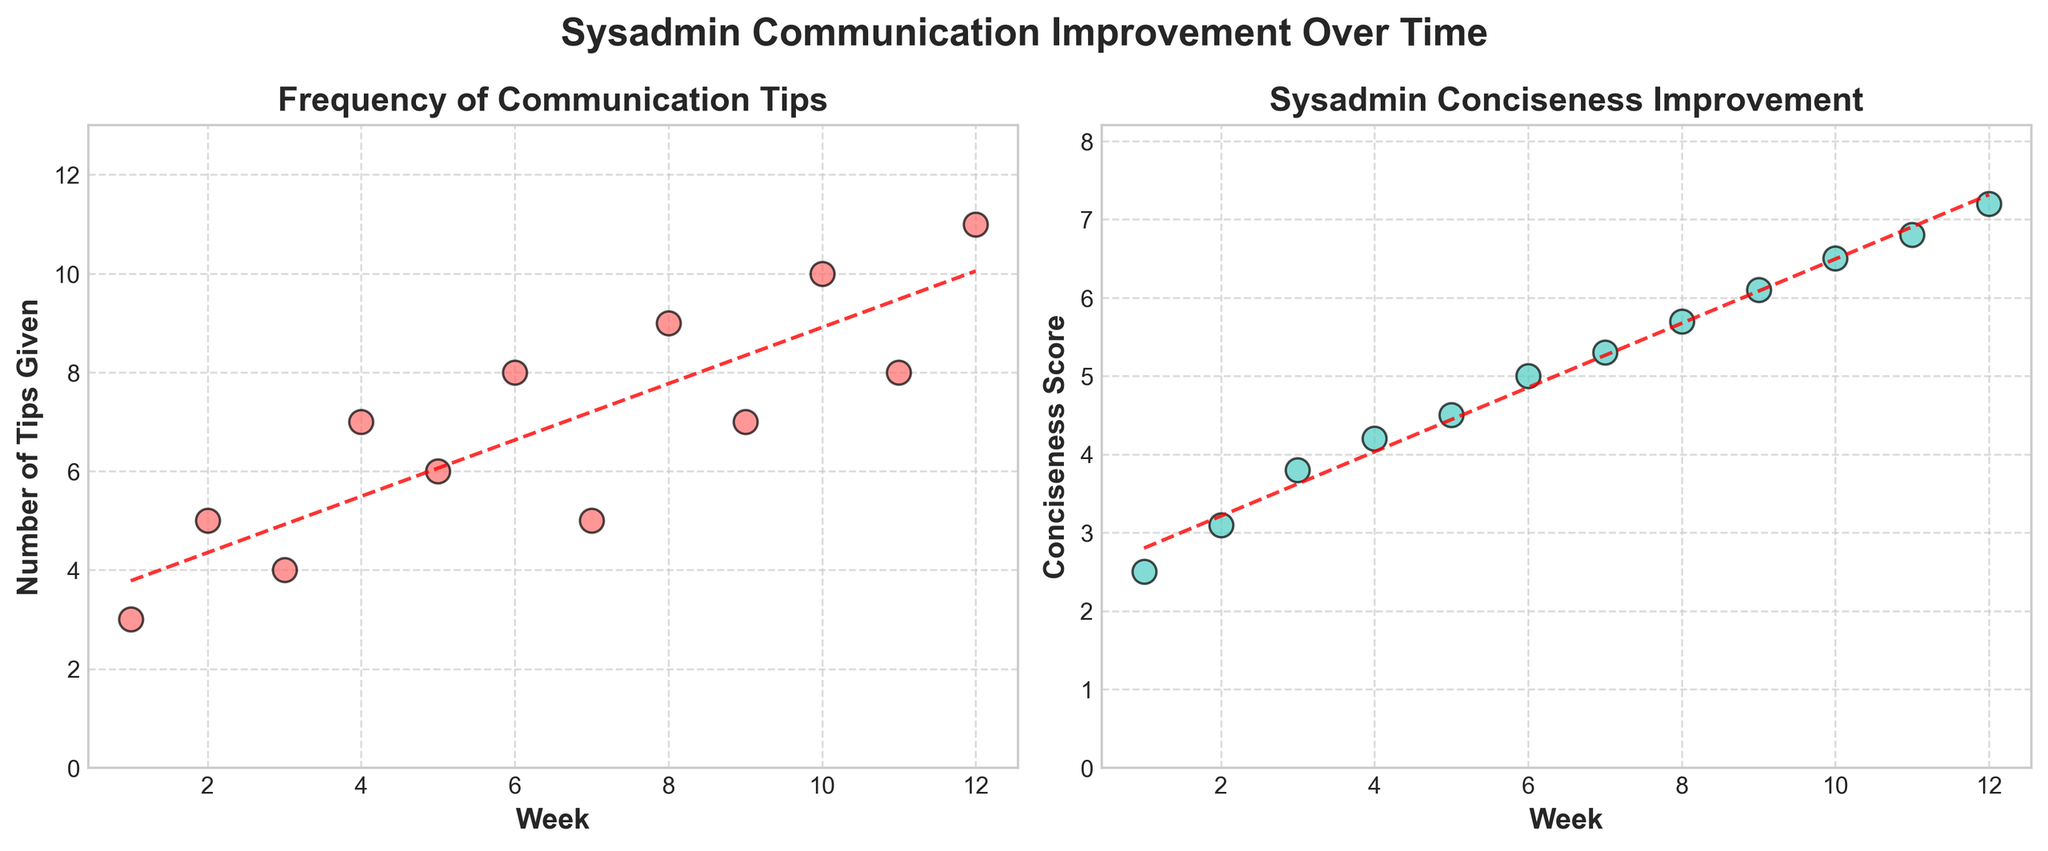What is the title of the overall figure? The title of the overall figure is found centered above the subplots in a large and bold font. It states "Sysadmin Communication Improvement Over Time".
Answer: Sysadmin Communication Improvement Over Time How many weeks are displayed in the plot? To determine the number of weeks, observe the x-axis of either subplot, which ranges from Week 1 to Week 12. This shows that there are 12 weeks displayed in the plot.
Answer: 12 What is the color used for the data points in the "Frequency of Communication Tips" subplot? The color of the data points in the "Frequency of Communication Tips" subplot is observed to be a shade of red.
Answer: Red What is the trend in the "Conciseness Score" subplot over the 12 weeks? Assess the overall direction of the data points and the trend line in the "Conciseness Score" subplot. It is observed that both the data points and the red dashed trend line indicate an increasing trend over time.
Answer: Increasing What is the maximum Conciseness Score recorded, and in which week does it occur? The maximum Conciseness Score can be identified from the vertical axis of the "Conciseness Score" subplot. The highest data point reaches a value of approximately 7.2, and it occurs in Week 12.
Answer: 7.2, Week 12 Compare the trend lines in both subplots. Which one has a steeper slope, suggesting a faster rate of change? Compare the angles of the red dashed trend lines in both subplots. The slope in the "Conciseness Score" subplot appears to be steeper, indicating a faster rate of change compared to the slope in the "Frequency of Communication Tips" subplot.
Answer: Conciseness Score What can you infer about the relationship between the number of tips given and the conciseness score over time? By observing both subplots, you can infer that as the number of tips given increases over the weeks, there is a corresponding increase in the conciseness score, suggesting a positive relationship between the two variables over time.
Answer: Positive relationship By how much did the number of tips given increase from Week 1 to Week 12? Look at the data points for both Week 1 and Week 12 in the "Frequency of Communication Tips" subplot. The number of tips given in Week 1 is 3, and in Week 12 it is 11. The increase is calculated as 11 - 3.
Answer: 8 What is the average number of tips given per week over the 12 weeks? To find the average, sum the number of tips given over the 12 weeks and divide by 12. The sum is (3 + 5 + 4 + 7 + 6 + 8 + 5 + 9 + 7 + 10 + 8 + 11) = 83. So, the average is 83/12.
Answer: 6.92 